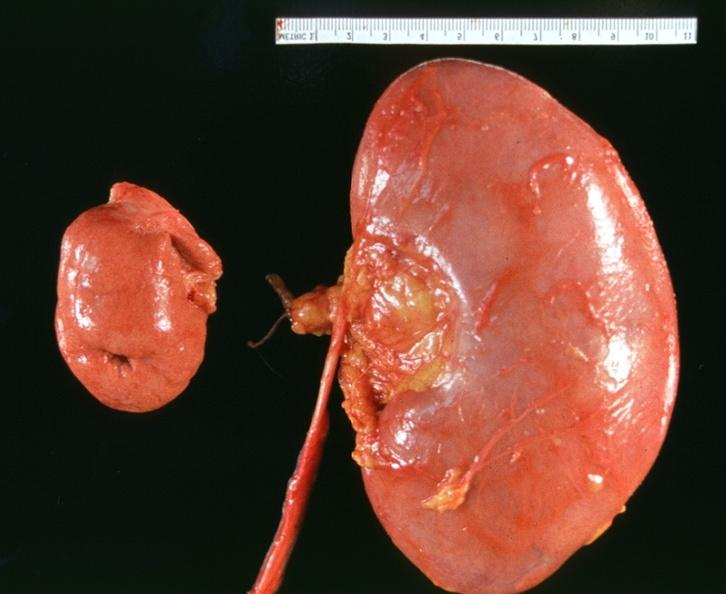does an opened peritoneal cavity cause by fibrous band strangulation show hyoplasia of kidney?
Answer the question using a single word or phrase. No 